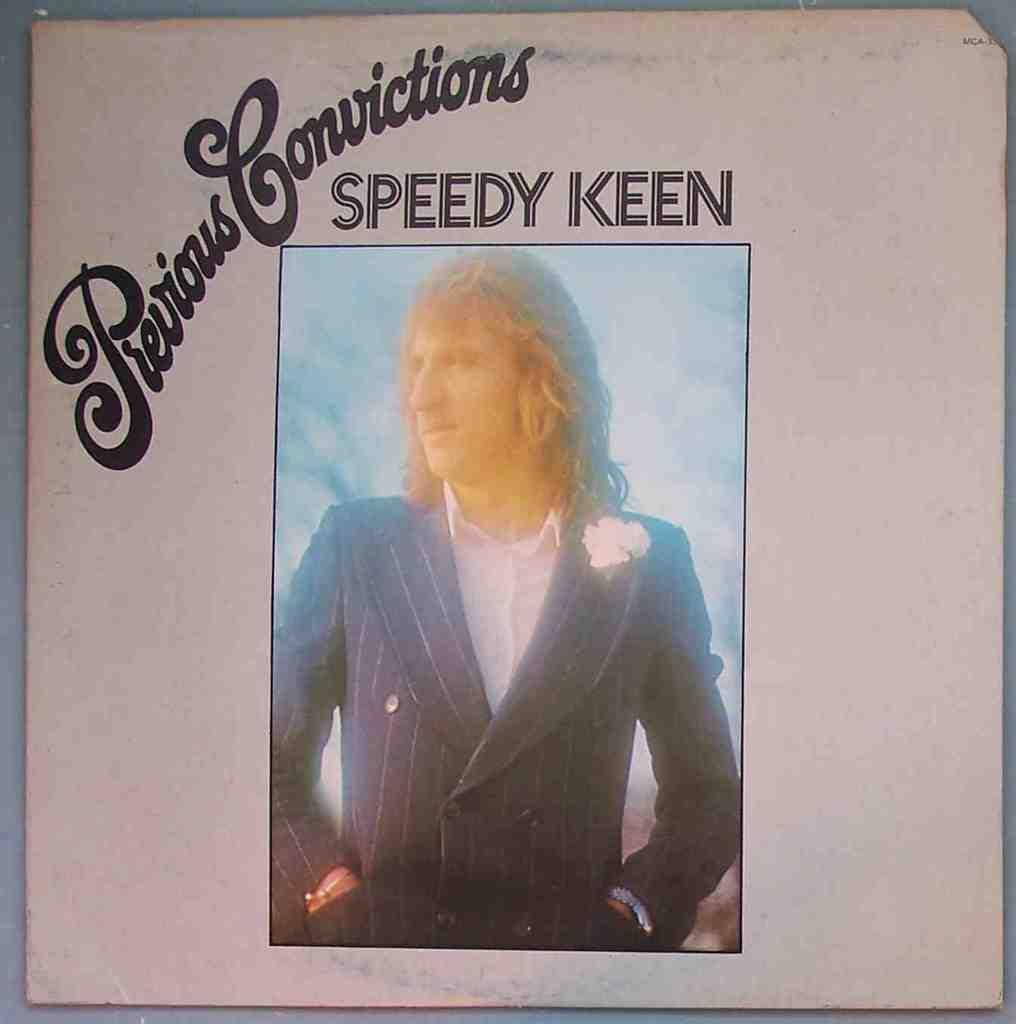What is featured in the image? There is a poster in the image. What can be seen on the poster? There is a person in the center of the poster. What is written on the poster? There is text at the top of the poster. What type of mint can be seen growing behind the curtain in the image? There is no mint or curtain present in the image; it only features a poster with a person and text. 